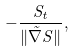Convert formula to latex. <formula><loc_0><loc_0><loc_500><loc_500>- \frac { S _ { t } } { \| \vec { \nabla } S \| } ,</formula> 